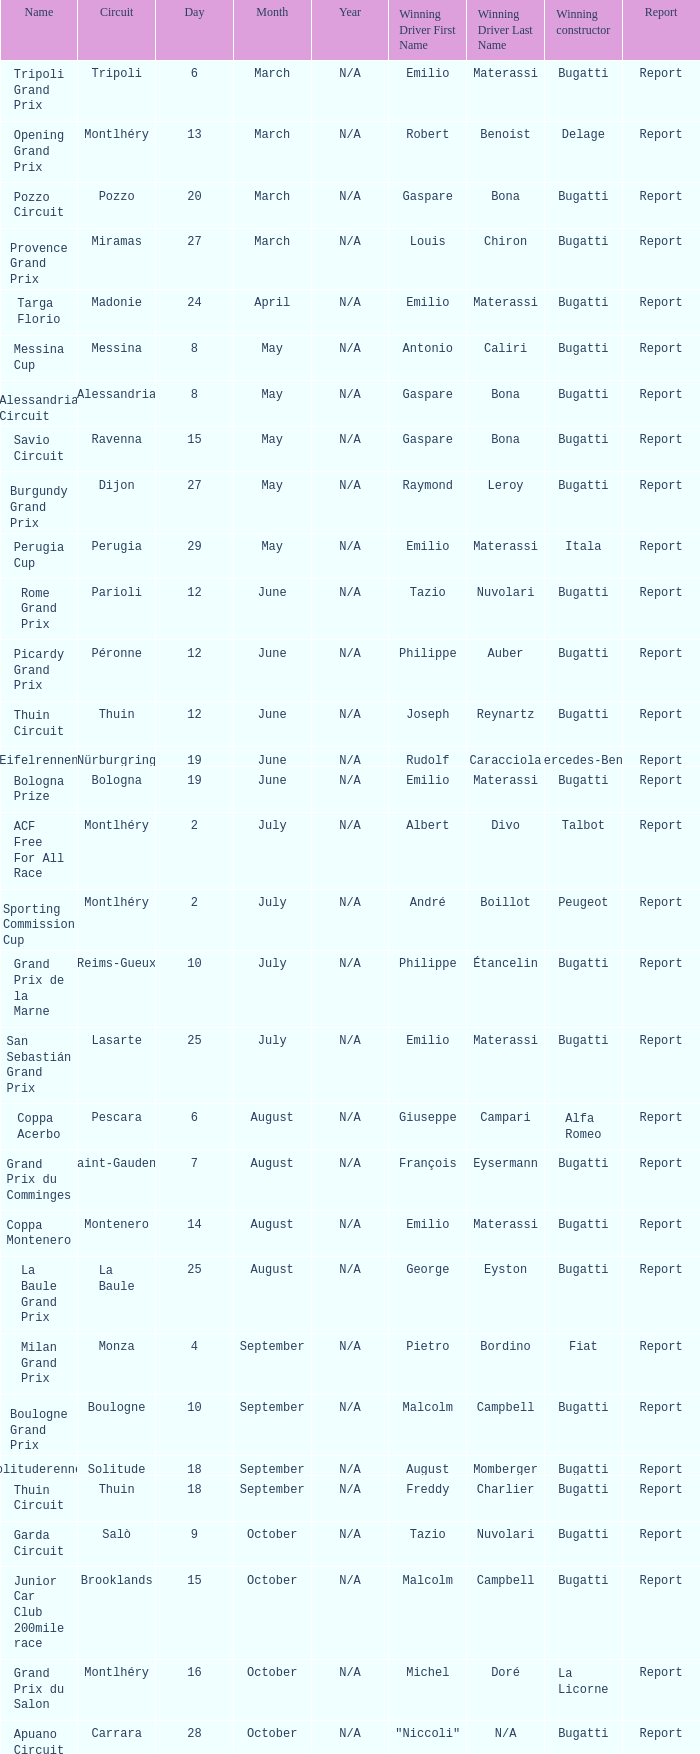When did Gaspare Bona win the Pozzo Circuit? 20 March. 